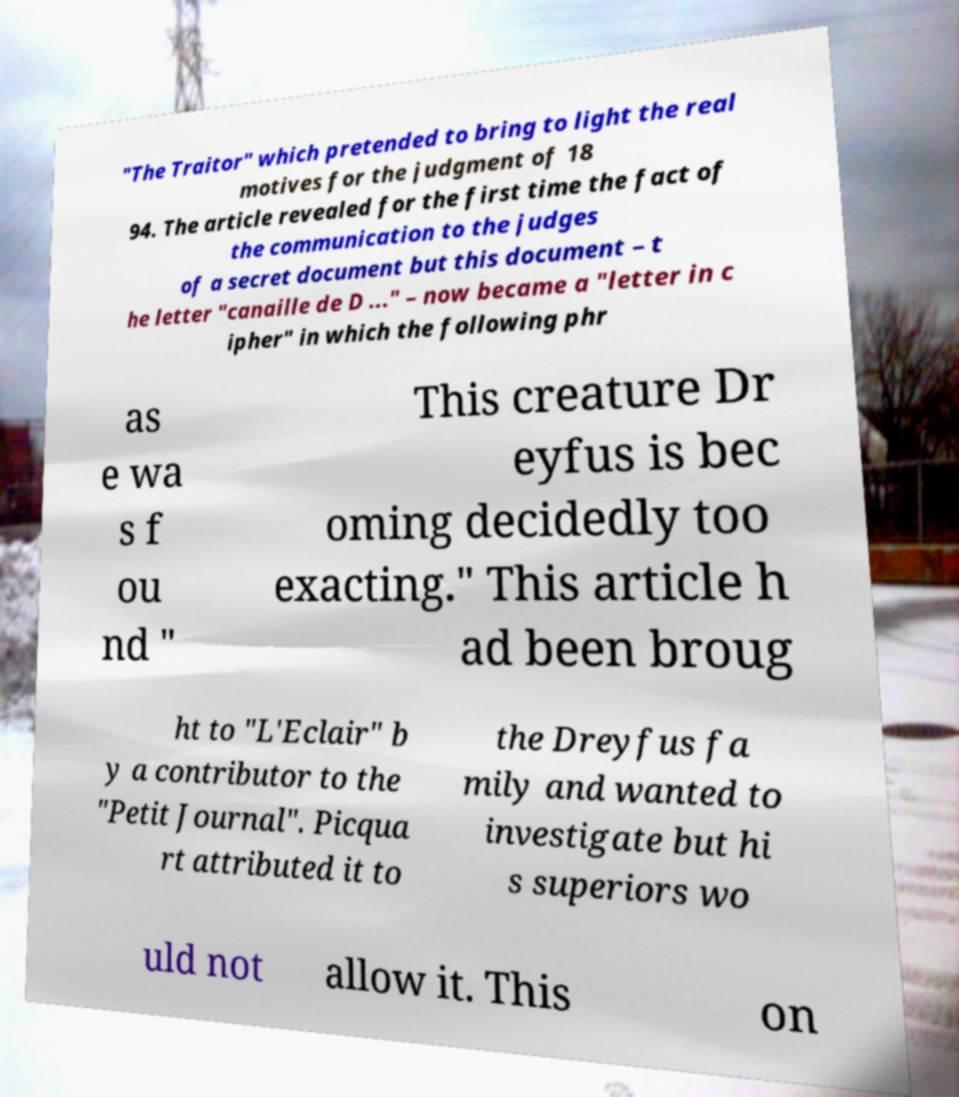I need the written content from this picture converted into text. Can you do that? "The Traitor" which pretended to bring to light the real motives for the judgment of 18 94. The article revealed for the first time the fact of the communication to the judges of a secret document but this document – t he letter "canaille de D ..." – now became a "letter in c ipher" in which the following phr as e wa s f ou nd " This creature Dr eyfus is bec oming decidedly too exacting." This article h ad been broug ht to "L'Eclair" b y a contributor to the "Petit Journal". Picqua rt attributed it to the Dreyfus fa mily and wanted to investigate but hi s superiors wo uld not allow it. This on 